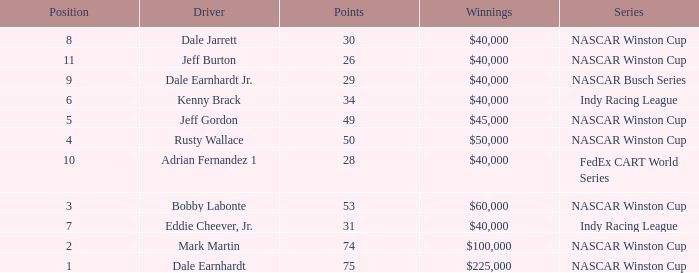What position did the driver earn 31 points? 7.0. Parse the table in full. {'header': ['Position', 'Driver', 'Points', 'Winnings', 'Series'], 'rows': [['8', 'Dale Jarrett', '30', '$40,000', 'NASCAR Winston Cup'], ['11', 'Jeff Burton', '26', '$40,000', 'NASCAR Winston Cup'], ['9', 'Dale Earnhardt Jr.', '29', '$40,000', 'NASCAR Busch Series'], ['6', 'Kenny Brack', '34', '$40,000', 'Indy Racing League'], ['5', 'Jeff Gordon', '49', '$45,000', 'NASCAR Winston Cup'], ['4', 'Rusty Wallace', '50', '$50,000', 'NASCAR Winston Cup'], ['10', 'Adrian Fernandez 1', '28', '$40,000', 'FedEx CART World Series'], ['3', 'Bobby Labonte', '53', '$60,000', 'NASCAR Winston Cup'], ['7', 'Eddie Cheever, Jr.', '31', '$40,000', 'Indy Racing League'], ['2', 'Mark Martin', '74', '$100,000', 'NASCAR Winston Cup'], ['1', 'Dale Earnhardt', '75', '$225,000', 'NASCAR Winston Cup']]} 